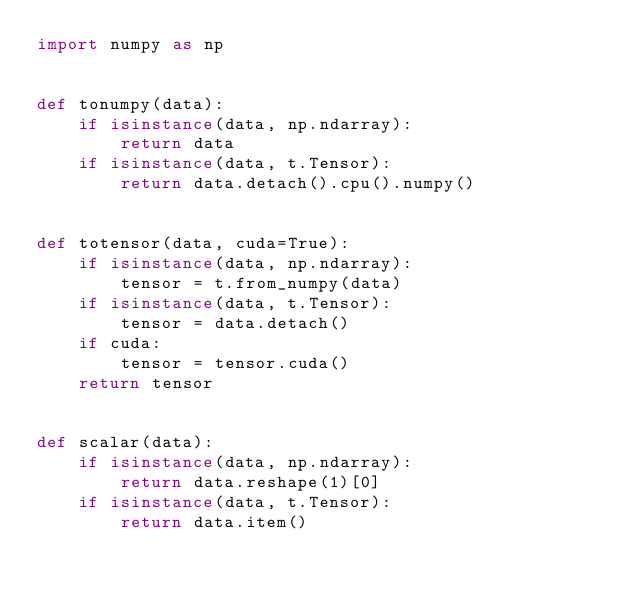Convert code to text. <code><loc_0><loc_0><loc_500><loc_500><_Python_>import numpy as np


def tonumpy(data):
    if isinstance(data, np.ndarray):
        return data
    if isinstance(data, t.Tensor):
        return data.detach().cpu().numpy()


def totensor(data, cuda=True):
    if isinstance(data, np.ndarray):
        tensor = t.from_numpy(data)
    if isinstance(data, t.Tensor):
        tensor = data.detach()
    if cuda:
        tensor = tensor.cuda()
    return tensor


def scalar(data):
    if isinstance(data, np.ndarray):
        return data.reshape(1)[0]
    if isinstance(data, t.Tensor):
        return data.item()</code> 